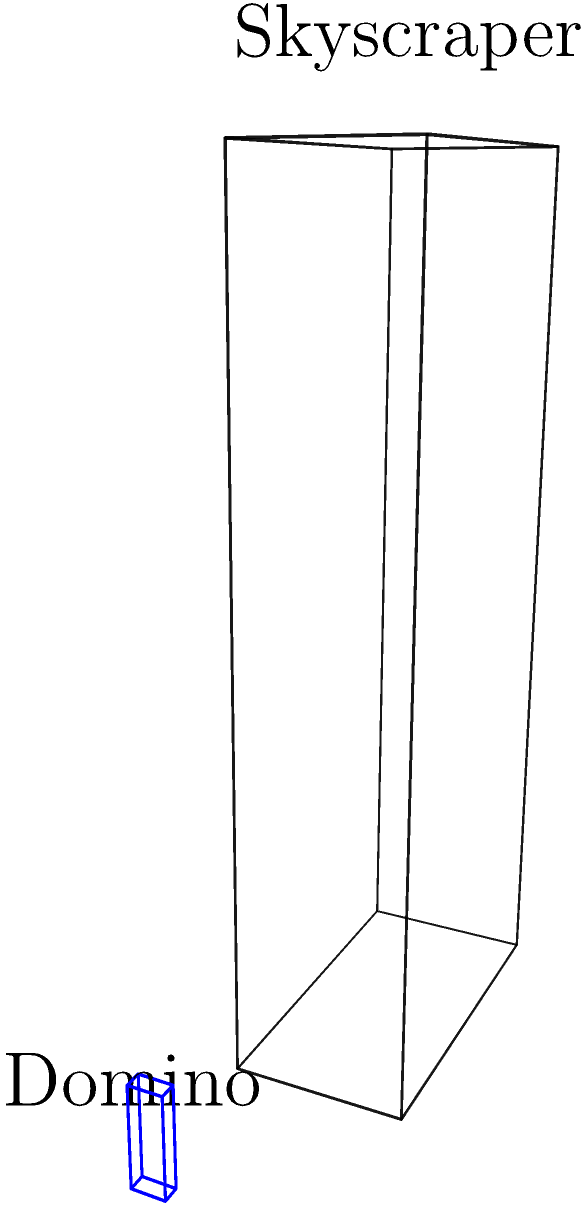You're planning to create a scaled-down version of a skyscraper using dominoes for your next social media post. The actual skyscraper measures 200 m in length, 100 m in width, and 500 m in height. If each domino measures 1 cm in width, 2 cm in length, and 6 cm in height, how many dominoes will you need to create a model that is 1/1000th the size of the actual skyscraper? Let's approach this step-by-step:

1. Calculate the dimensions of the scaled-down skyscraper:
   - Length: $200 \text{ m} \times \frac{1}{1000} = 0.2 \text{ m} = 20 \text{ cm}$
   - Width: $100 \text{ m} \times \frac{1}{1000} = 0.1 \text{ m} = 10 \text{ cm}$
   - Height: $500 \text{ m} \times \frac{1}{1000} = 0.5 \text{ m} = 50 \text{ cm}$

2. Calculate how many dominoes are needed for each dimension:
   - Length: $20 \text{ cm} \div 2 \text{ cm} = 10$ dominoes
   - Width: $10 \text{ cm} \div 1 \text{ cm} = 10$ dominoes
   - Height: $50 \text{ cm} \div 6 \text{ cm} = 8.33$ (round up to 9) dominoes

3. Calculate the total number of dominoes:
   $10 \times 10 \times 9 = 900$ dominoes

Therefore, you will need 900 dominoes to create the scaled-down model of the skyscraper.
Answer: 900 dominoes 